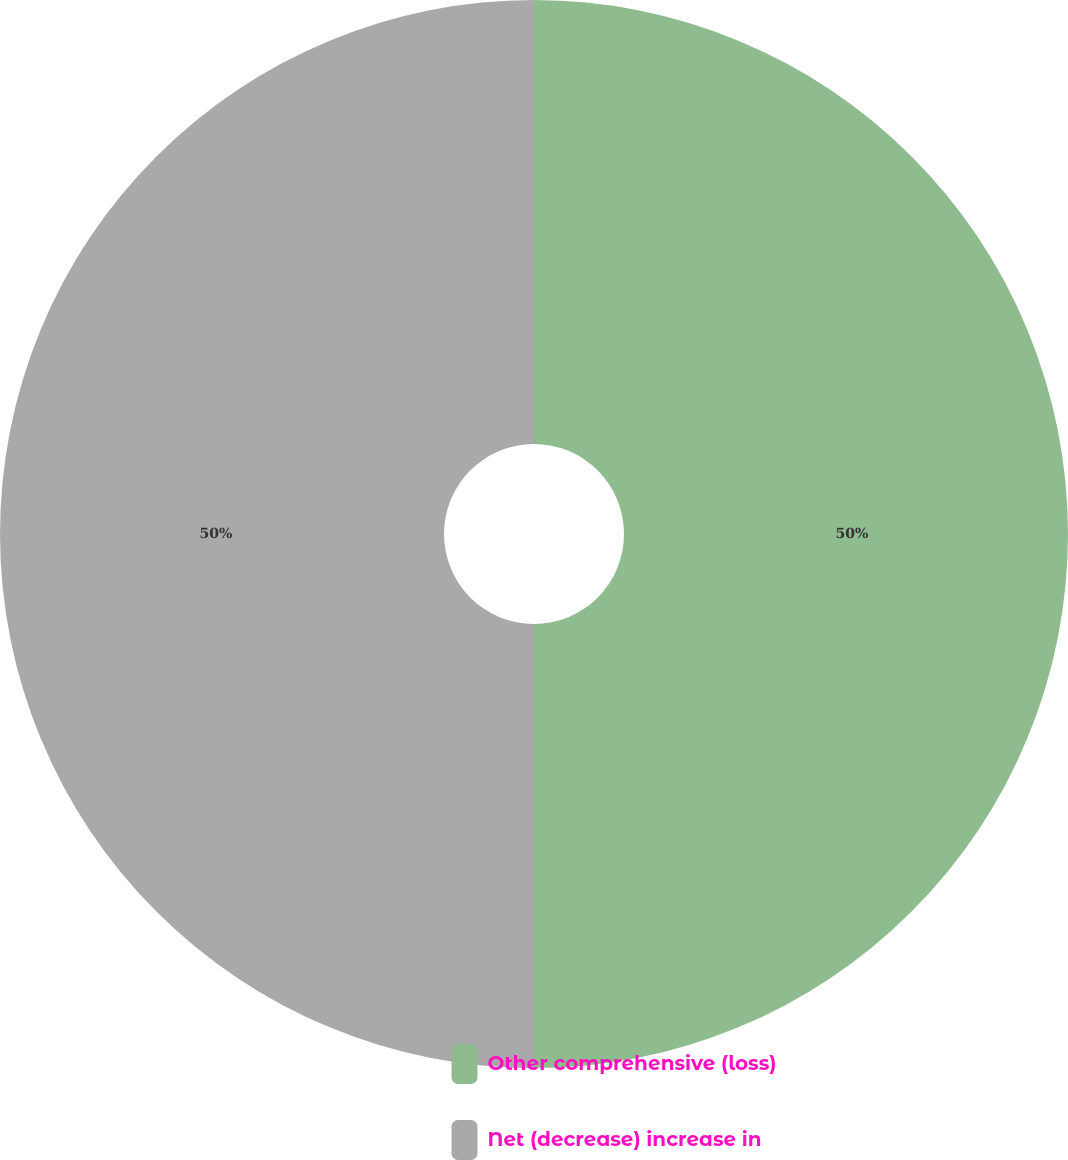Convert chart to OTSL. <chart><loc_0><loc_0><loc_500><loc_500><pie_chart><fcel>Other comprehensive (loss)<fcel>Net (decrease) increase in<nl><fcel>50.0%<fcel>50.0%<nl></chart> 